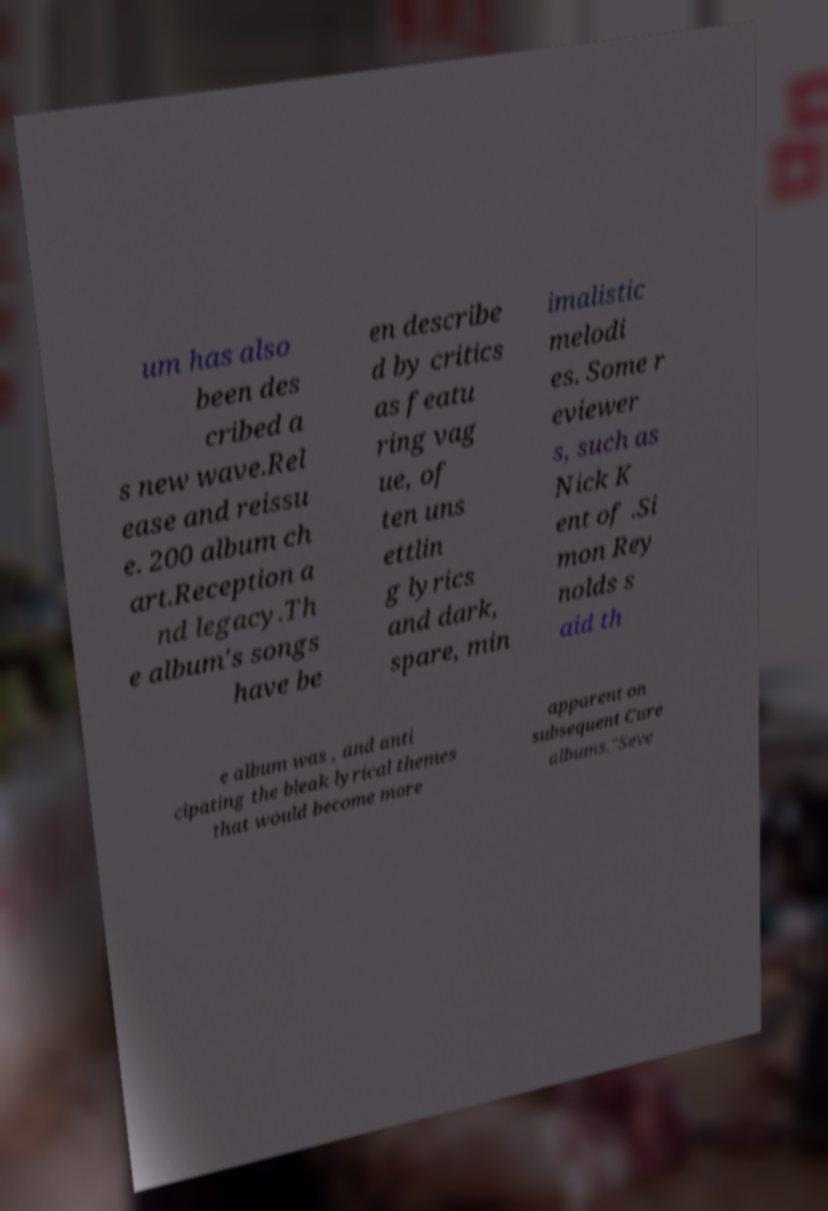Can you read and provide the text displayed in the image?This photo seems to have some interesting text. Can you extract and type it out for me? um has also been des cribed a s new wave.Rel ease and reissu e. 200 album ch art.Reception a nd legacy.Th e album's songs have be en describe d by critics as featu ring vag ue, of ten uns ettlin g lyrics and dark, spare, min imalistic melodi es. Some r eviewer s, such as Nick K ent of .Si mon Rey nolds s aid th e album was , and anti cipating the bleak lyrical themes that would become more apparent on subsequent Cure albums."Seve 